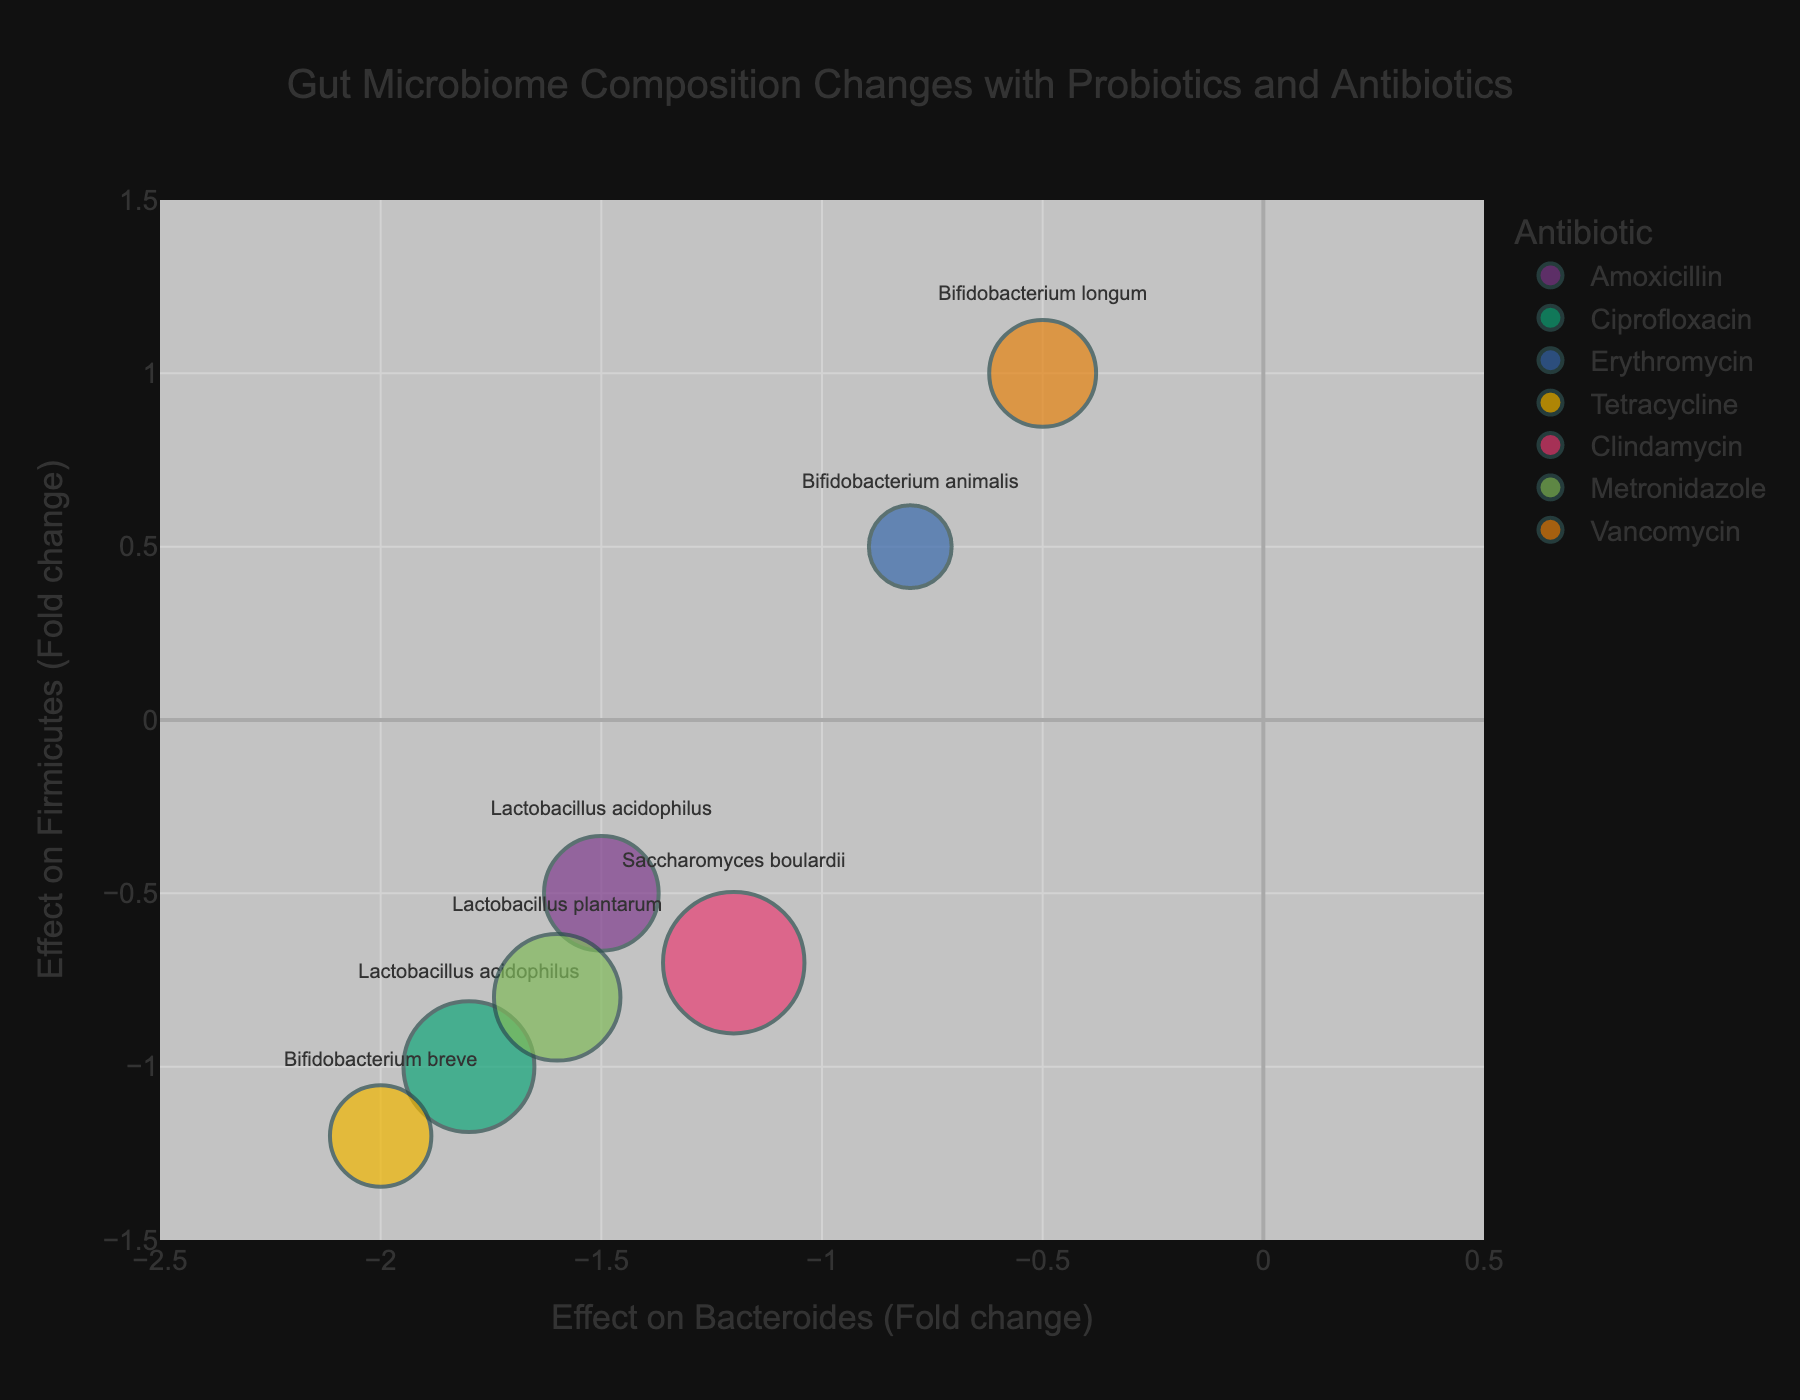Which probiotic and antibiotic pair resulted in the highest increase in Proteobacteria? By examining the size of the bubbles, which represents the effect on Proteobacteria, the pair with the largest bubble signifies the highest increase. Here, Saccharomyces boulardii combined with Clindamycin has the largest bubble indicating a fold change of 3.5, the highest increase among the data points.
Answer: Saccharomyces boulardii and Clindamycin How did Lactobacillus acidophilus affect Firmicutes across different antibiotics? To answer this, observe the y-axis values corresponding to Lactobacillus acidophilus with different antibiotics. Amoxicillin, Ciprofloxacin, and Erythromycin correspond to y-axis values of -0.5, -1.0, and 0.5, respectively.
Answer: -0.5, -1.0, and 0.5 Which antibiotic resulted in the greatest overall reduction in Bacteroides? To identify this, find the lowest x-axis value in the chart. Bifidobacterium breve with Tetracycline shows the most negative effect on Bacteroides with a fold change of -2.0.
Answer: Tetracycline Among probiotics administered with Erythromycin, which one showed the highest diversity index? Look at the hover information for probiotics with Erythromycin and compare their Diversity Index values. Bifidobacterium animalis with Erythromycin has a Diversity Index of 0.9, which is the highest for this antibiotic.
Answer: Bifidobacterium animalis What is the effect of Bifidobacterium longum on both Bacteroides and Firmicutes with Vancomycin? Find the specific data point for Bifidobacterium longum with Vancomycin and read the x and y-axis values: the fold change for Bacteroides is -0.5 and for Firmicutes is 1.0.
Answer: -0.5 and 1.0 Which combination led to the lowest Diversity Index, and what are its effects on Firmicutes and Proteobacteria? Find the smallest bubble on the chart, which indicates the lowest Diversity Index. Saccharomyces boulardii with Clindamycin has the lowest Diversity Index of 0.4. Its effects on Firmicutes and Proteobacteria are -0.7 and 3.5, respectively.
Answer: Saccharomyces boulardii and Clindamycin; -0.7 and 3.5 If you average the effects on Bacteroides for all Lactobacillus species, what would it be? Calculate the average fold change on Bacteroides for Lactobacillus acidophilus (with Amoxicillin, Ciprofloxacin) and Lactobacillus plantarum (with Metronidazole). These values are -1.5, -1.8, and -1.6. The average is (-1.5 + -1.8 + -1.6) / 3 = -1.63.
Answer: -1.63 Comparing Bifidobacterium animalis and Bifidobacterium longum, which showed a greater increase in Firmicutes and by how much? Look at the y-axis values for Bifidobacterium animalis (0.5 with Erythromycin) and Bifidobacterium longum (1.0 with Vancomycin). Calculate the difference: 1.0 - 0.5 = 0.5. Bifidobacterium longum showed a greater increase by 0.5.
Answer: Bifidobacterium longum; 0.5 